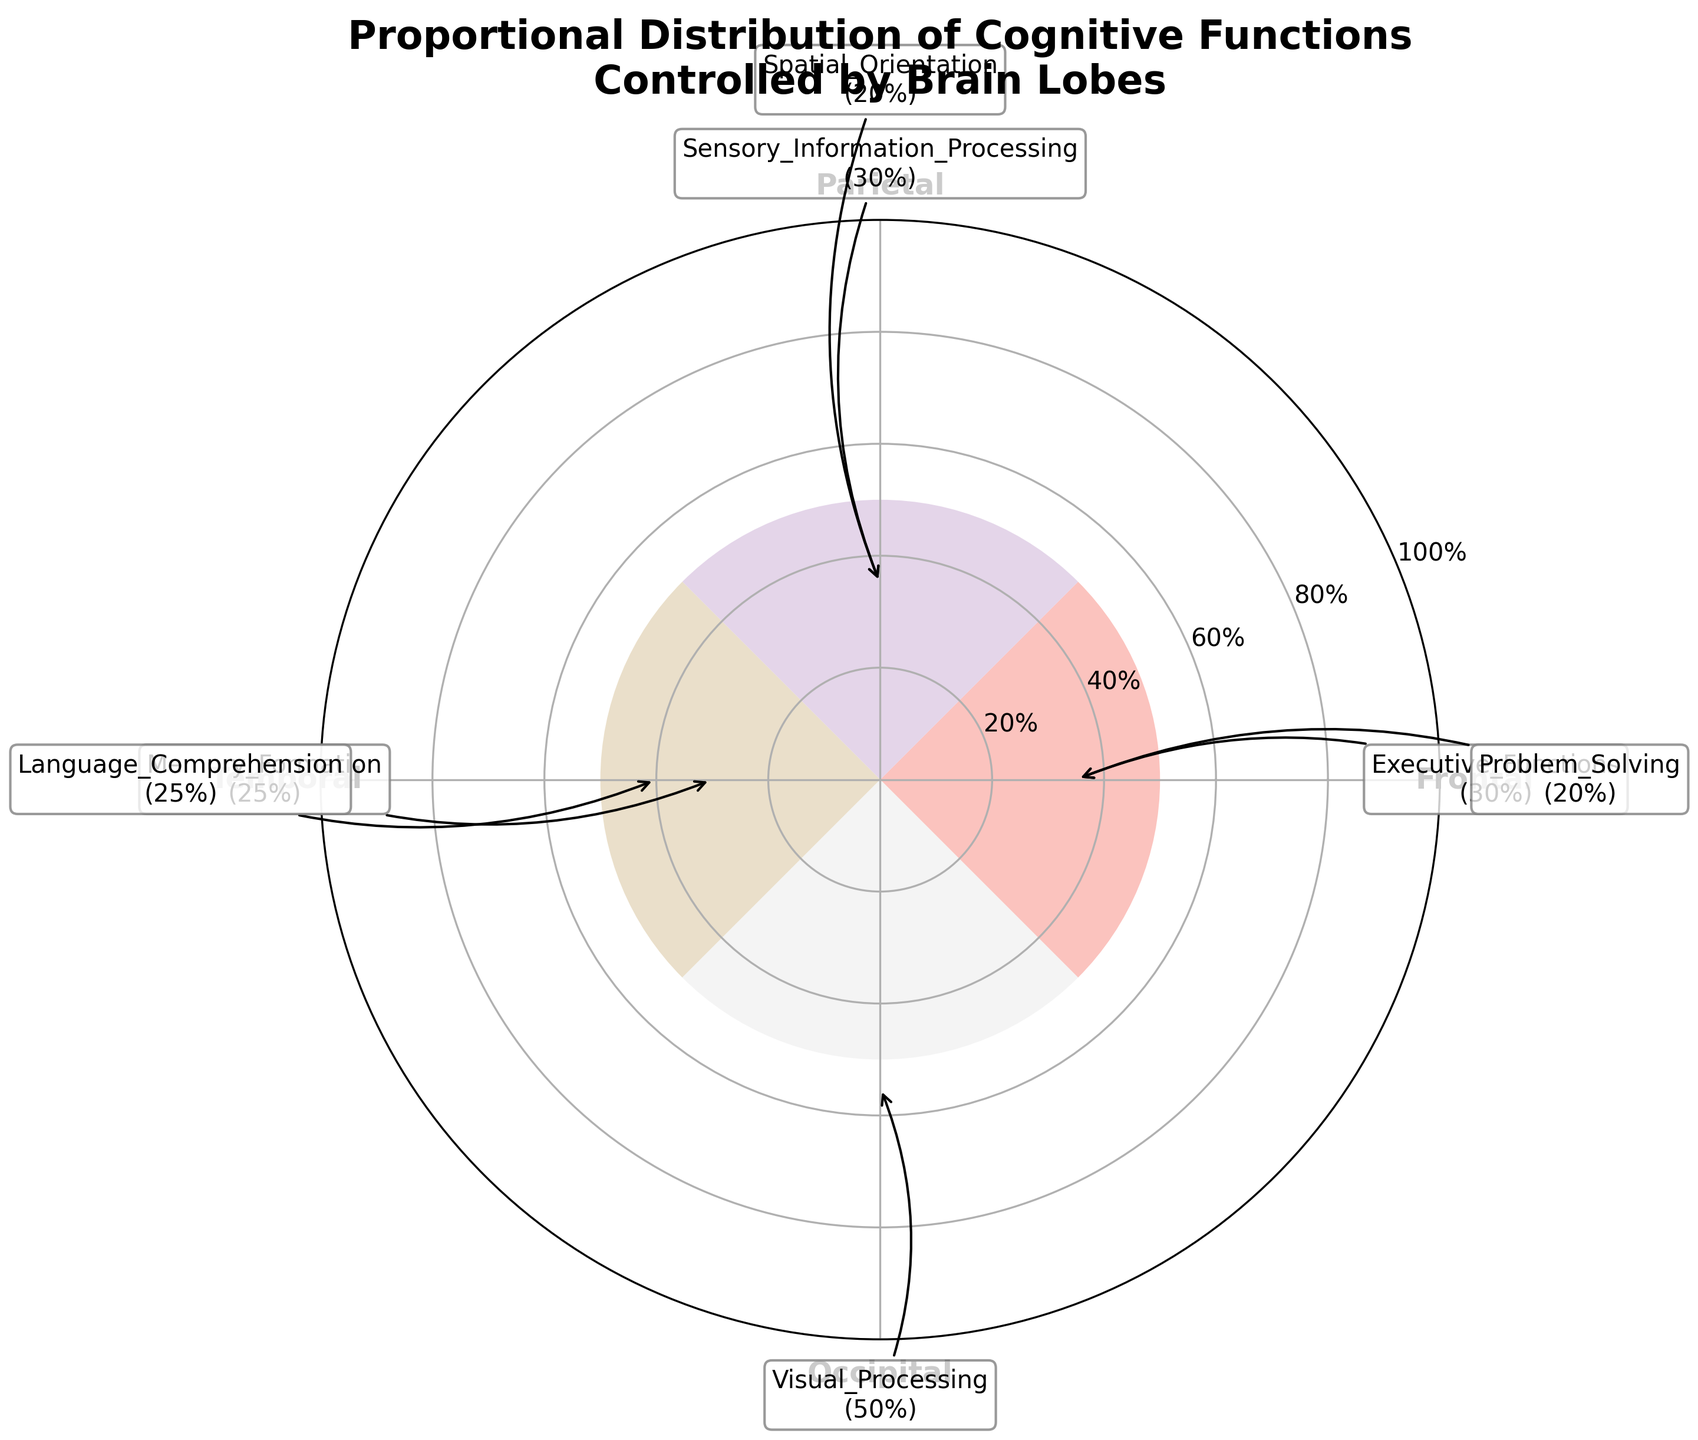What's the title of the chart? The title is located at the top of the chart. It reads "Proportional Distribution of Cognitive Functions Controlled by Brain Lobes".
Answer: Proportional Distribution of Cognitive Functions Controlled by Brain Lobes How many brain lobes are represented in the chart? The chart has one bar per brain lobe, each labeled on the outer circle of the polar area chart. There are four brain lobes: Frontal, Parietal, Temporal, and Occipital.
Answer: Four Which brain lobe has the highest combined proportion of cognitive functions? By looking at the length of the bars, the Occipital lobe has the largest bar. This represents Visual Processing with a 50% proportion, the highest combined proportion.
Answer: Occipital What is the combined proportion of cognitive functions for the Frontal lobe? The Frontal lobe has two bars representing Executive Functions (30%) and Problem Solving (20%). Summing these up, 30% + 20% = 50%.
Answer: 50% Are there any lobes that have the same combined proportion of cognitive functions? The Frontal lobe and the Occipital lobe each have a combined proportion of 50%; Frontal has 30% for Executive Functions and 20% for Problem Solving, and Occipital has 50% for Visual Processing.
Answer: Yes Which cognitive function has the second highest proportion, and which lobe does it belong to? The second highest proportion is 30%, shared by Executive Functions (Frontal lobe) and Sensory Information Processing (Parietal lobe).
Answer: Executive Functions (Frontal lobe) and Sensory Information Processing (Parietal lobe) Compare the proportions of cognitive functions between Parietal and Temporal lobes. Which lobe has a higher overall combined proportion? The Parietal lobe has Sensory Information Processing (30%) and Spatial Orientation (20%), for a total of 50%. The Temporal lobe has Memory Formation (25%) and Language Comprehension (25%), for a total of 50%. Both have the same combined proportion.
Answer: Both have 50% What is the proportion of Language Comprehension function in the Temporal lobe? The Language Comprehension function in the Temporal lobe is annotated with a proportion of 25% in the chart.
Answer: 25% Which lobe has the smallest combined proportion of cognitive functions and what are these functions? The Parietal lobe has Sensory Information Processing (30%) and Spatial Orientation (20%) for a combined proportion of 50%, but since the Temporal lobe also has a combined proportion of 50%, neither lobe stands out as having the smallest combined proportion. Therefore, it's a tie between Parietal and Temporal with 50% each.
Answer: It's a tie between Parietal and Temporal, both have 50% Is there a cognitive function shared between the Frontal and any other lobe? By examining the annotations, no cognitive functions overlap between the Frontal lobe and any other lobes in the given data.
Answer: No 